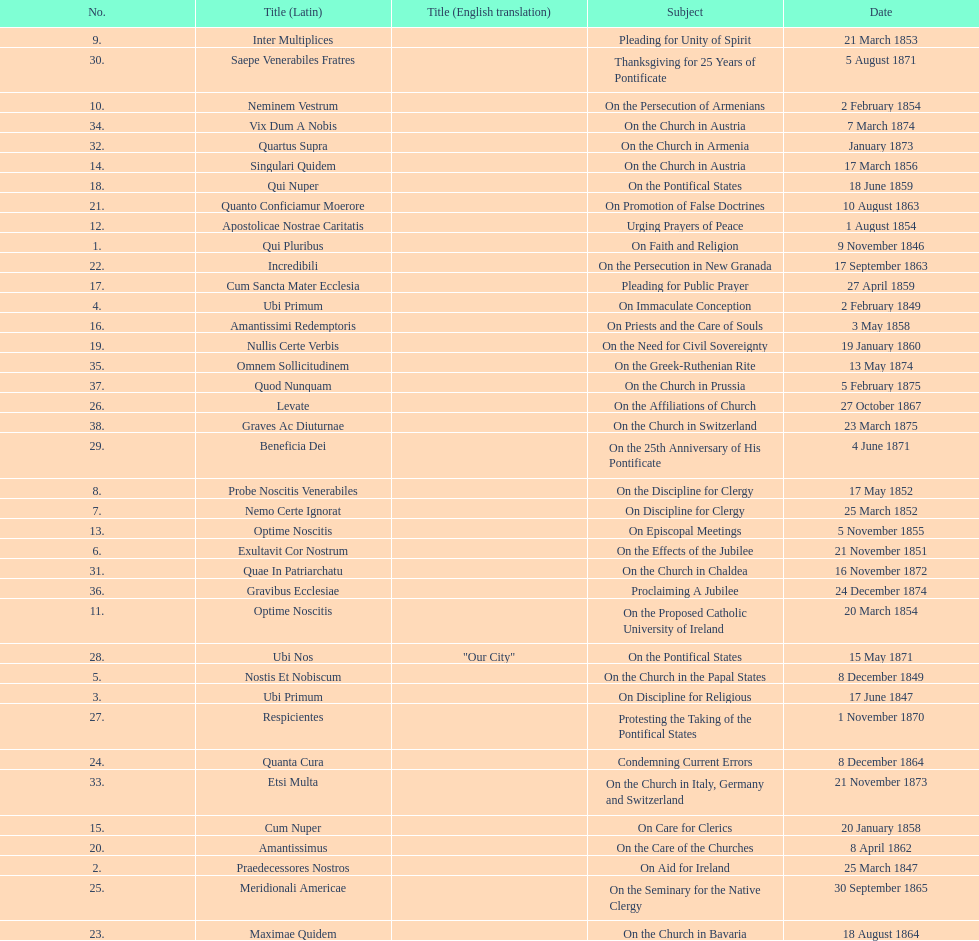How often was an encyclical sent in january? 3. 